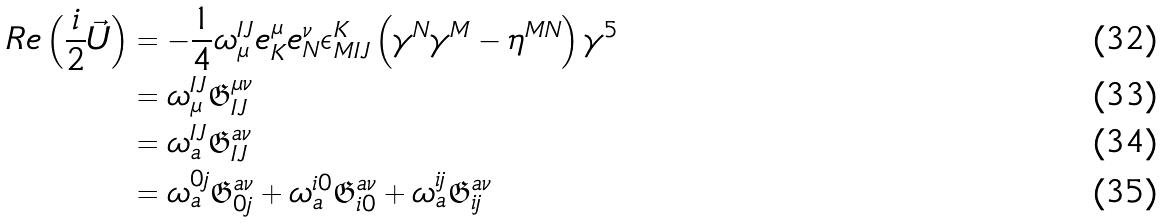Convert formula to latex. <formula><loc_0><loc_0><loc_500><loc_500>R e \left ( \frac { i } { 2 } \vec { U } \right ) & = - \frac { 1 } { 4 } \omega ^ { I J } _ { \mu } e ^ { \mu } _ { K } e ^ { \nu } _ { N } \epsilon _ { M I J } ^ { K } \left ( \gamma ^ { N } \gamma ^ { M } - \eta ^ { M N } \right ) \gamma ^ { 5 } \\ & = \omega ^ { I J } _ { \mu } \mathfrak { G } ^ { \mu \nu } _ { I J } \\ & = \omega ^ { I J } _ { a } \mathfrak { G } ^ { a \nu } _ { I J } \\ & = \omega ^ { 0 j } _ { a } \mathfrak { G } ^ { a \nu } _ { 0 j } + \omega ^ { i 0 } _ { a } \mathfrak { G } ^ { a \nu } _ { i 0 } + \omega ^ { i j } _ { a } \mathfrak { G } ^ { a \nu } _ { i j }</formula> 